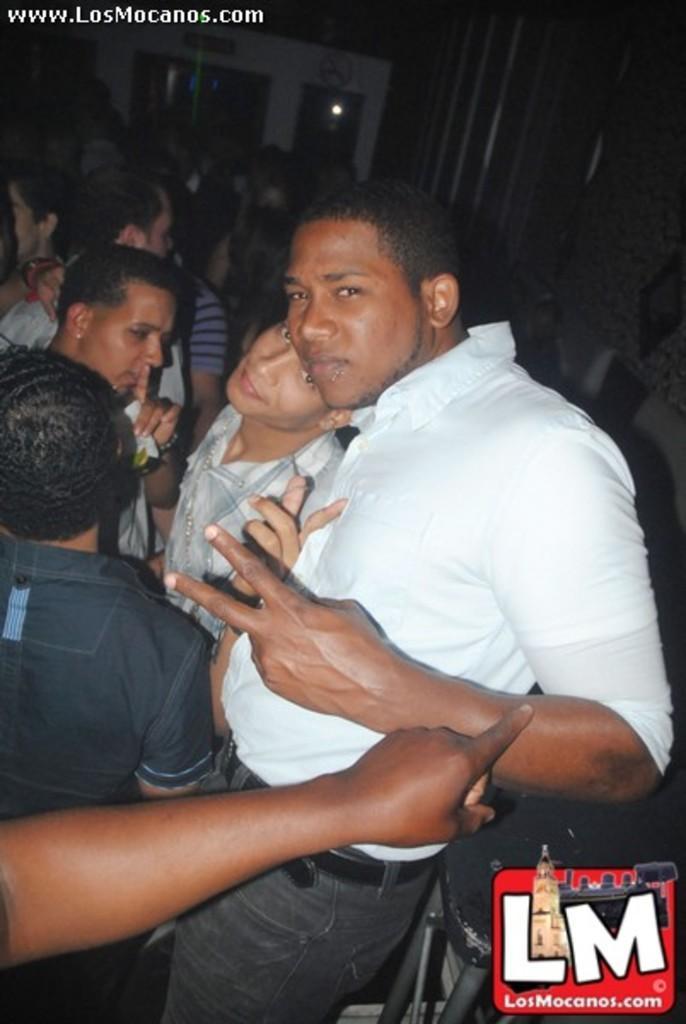Could you give a brief overview of what you see in this image? In front of the image there is some object. There are people standing. In the background of the image there are glass doors. There are boards on the wall. There is some text at the top of the image. There is a watermark at the bottom of the image. 